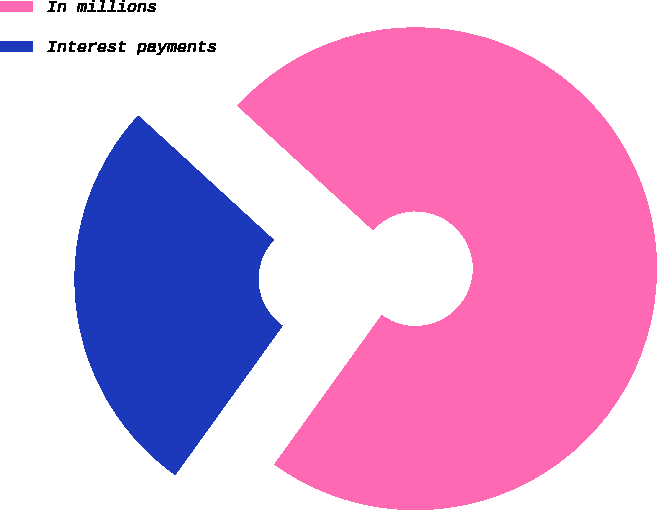<chart> <loc_0><loc_0><loc_500><loc_500><pie_chart><fcel>In millions<fcel>Interest payments<nl><fcel>73.11%<fcel>26.89%<nl></chart> 